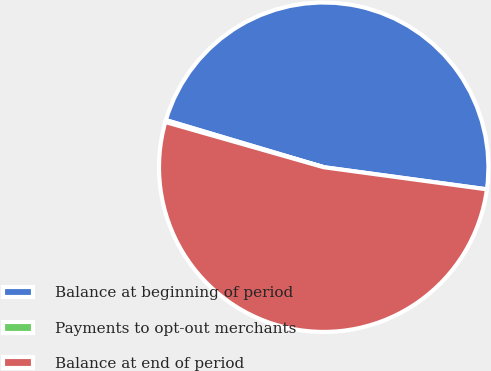<chart> <loc_0><loc_0><loc_500><loc_500><pie_chart><fcel>Balance at beginning of period<fcel>Payments to opt-out merchants<fcel>Balance at end of period<nl><fcel>47.53%<fcel>0.19%<fcel>52.28%<nl></chart> 